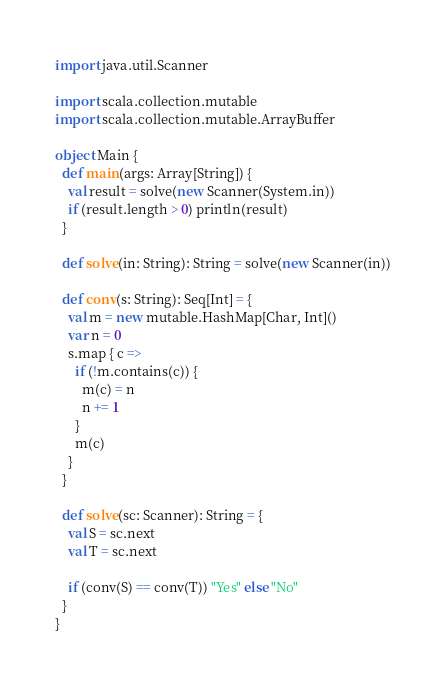<code> <loc_0><loc_0><loc_500><loc_500><_Scala_>import java.util.Scanner

import scala.collection.mutable
import scala.collection.mutable.ArrayBuffer

object Main {
  def main(args: Array[String]) {
    val result = solve(new Scanner(System.in))
    if (result.length > 0) println(result)
  }

  def solve(in: String): String = solve(new Scanner(in))

  def conv(s: String): Seq[Int] = {
    val m = new mutable.HashMap[Char, Int]()
    var n = 0
    s.map { c =>
      if (!m.contains(c)) {
        m(c) = n
        n += 1
      }
      m(c)
    }
  }

  def solve(sc: Scanner): String = {
    val S = sc.next
    val T = sc.next

    if (conv(S) == conv(T)) "Yes" else "No"
  }
}
</code> 